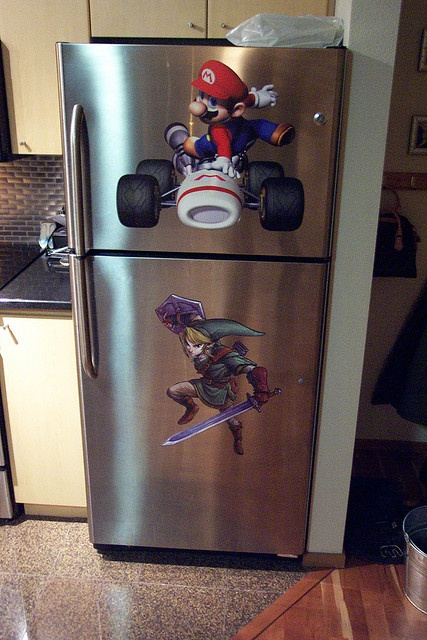Describe the objects in this image and their specific colors. I can see a refrigerator in tan, gray, maroon, and black tones in this image. 